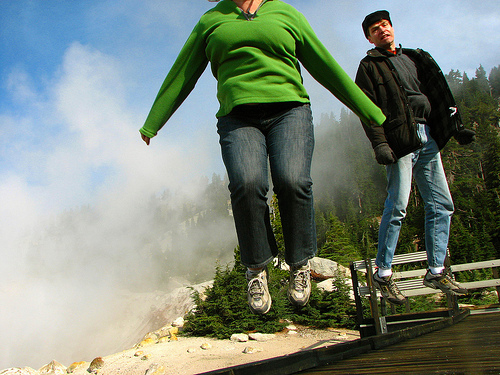<image>
Is there a woman next to the man? Yes. The woman is positioned adjacent to the man, located nearby in the same general area. 